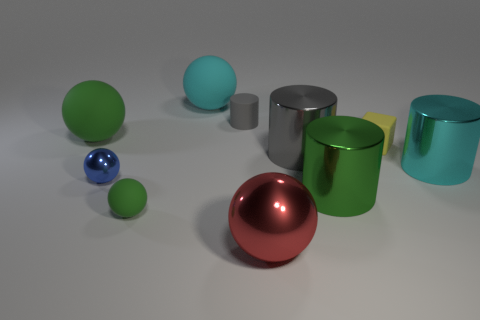There is another cylinder that is the same color as the tiny matte cylinder; what material is it?
Offer a terse response. Metal. Are there fewer tiny rubber spheres on the left side of the big green matte object than rubber objects in front of the tiny metallic sphere?
Offer a very short reply. Yes. What number of other things are there of the same shape as the small green thing?
Your response must be concise. 4. There is a matte sphere that is in front of the large green object that is in front of the matte thing to the right of the gray rubber cylinder; what is its size?
Provide a succinct answer. Small. How many brown things are rubber cubes or tiny metal spheres?
Provide a succinct answer. 0. There is a large green thing that is in front of the green matte ball that is behind the big cyan metal cylinder; what is its shape?
Keep it short and to the point. Cylinder. Is the size of the green ball in front of the large gray thing the same as the green ball to the left of the small rubber sphere?
Make the answer very short. No. Are there any tiny blue cylinders that have the same material as the large green ball?
Make the answer very short. No. There is a object that is the same color as the small rubber cylinder; what size is it?
Your answer should be very brief. Large. Are there any tiny yellow blocks that are in front of the cylinder to the left of the large metallic cylinder to the left of the large green metal object?
Your response must be concise. Yes. 